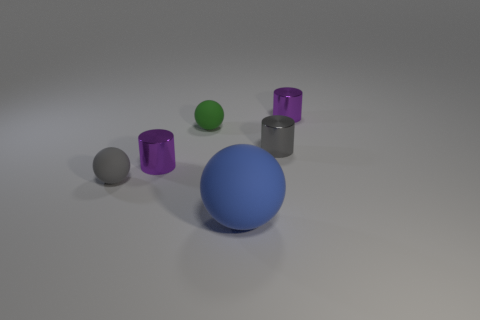Does the matte thing in front of the tiny gray sphere have the same shape as the gray object that is to the left of the big blue rubber ball?
Ensure brevity in your answer.  Yes. What material is the gray object that is to the left of the tiny purple object that is on the left side of the purple cylinder that is behind the tiny green rubber thing?
Give a very brief answer. Rubber. What material is the green object that is the same size as the gray cylinder?
Keep it short and to the point. Rubber. Do the small metal thing on the left side of the tiny green matte object and the small metallic thing to the right of the small gray metal object have the same color?
Offer a terse response. Yes. What shape is the big blue object that is in front of the purple thing in front of the green sphere?
Offer a very short reply. Sphere. What shape is the small gray object behind the tiny rubber ball in front of the purple metallic object in front of the green matte ball?
Your response must be concise. Cylinder. What number of other small metallic things have the same shape as the green object?
Keep it short and to the point. 0. There is a purple shiny object in front of the tiny gray shiny cylinder; how many things are on the right side of it?
Provide a short and direct response. 4. How many rubber things are tiny gray things or large objects?
Provide a succinct answer. 2. Are there any gray balls that have the same material as the green thing?
Make the answer very short. Yes. 